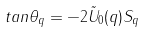Convert formula to latex. <formula><loc_0><loc_0><loc_500><loc_500>t a n \theta _ { q } = - 2 { \tilde { U } } _ { 0 } ( { q } ) S _ { q }</formula> 